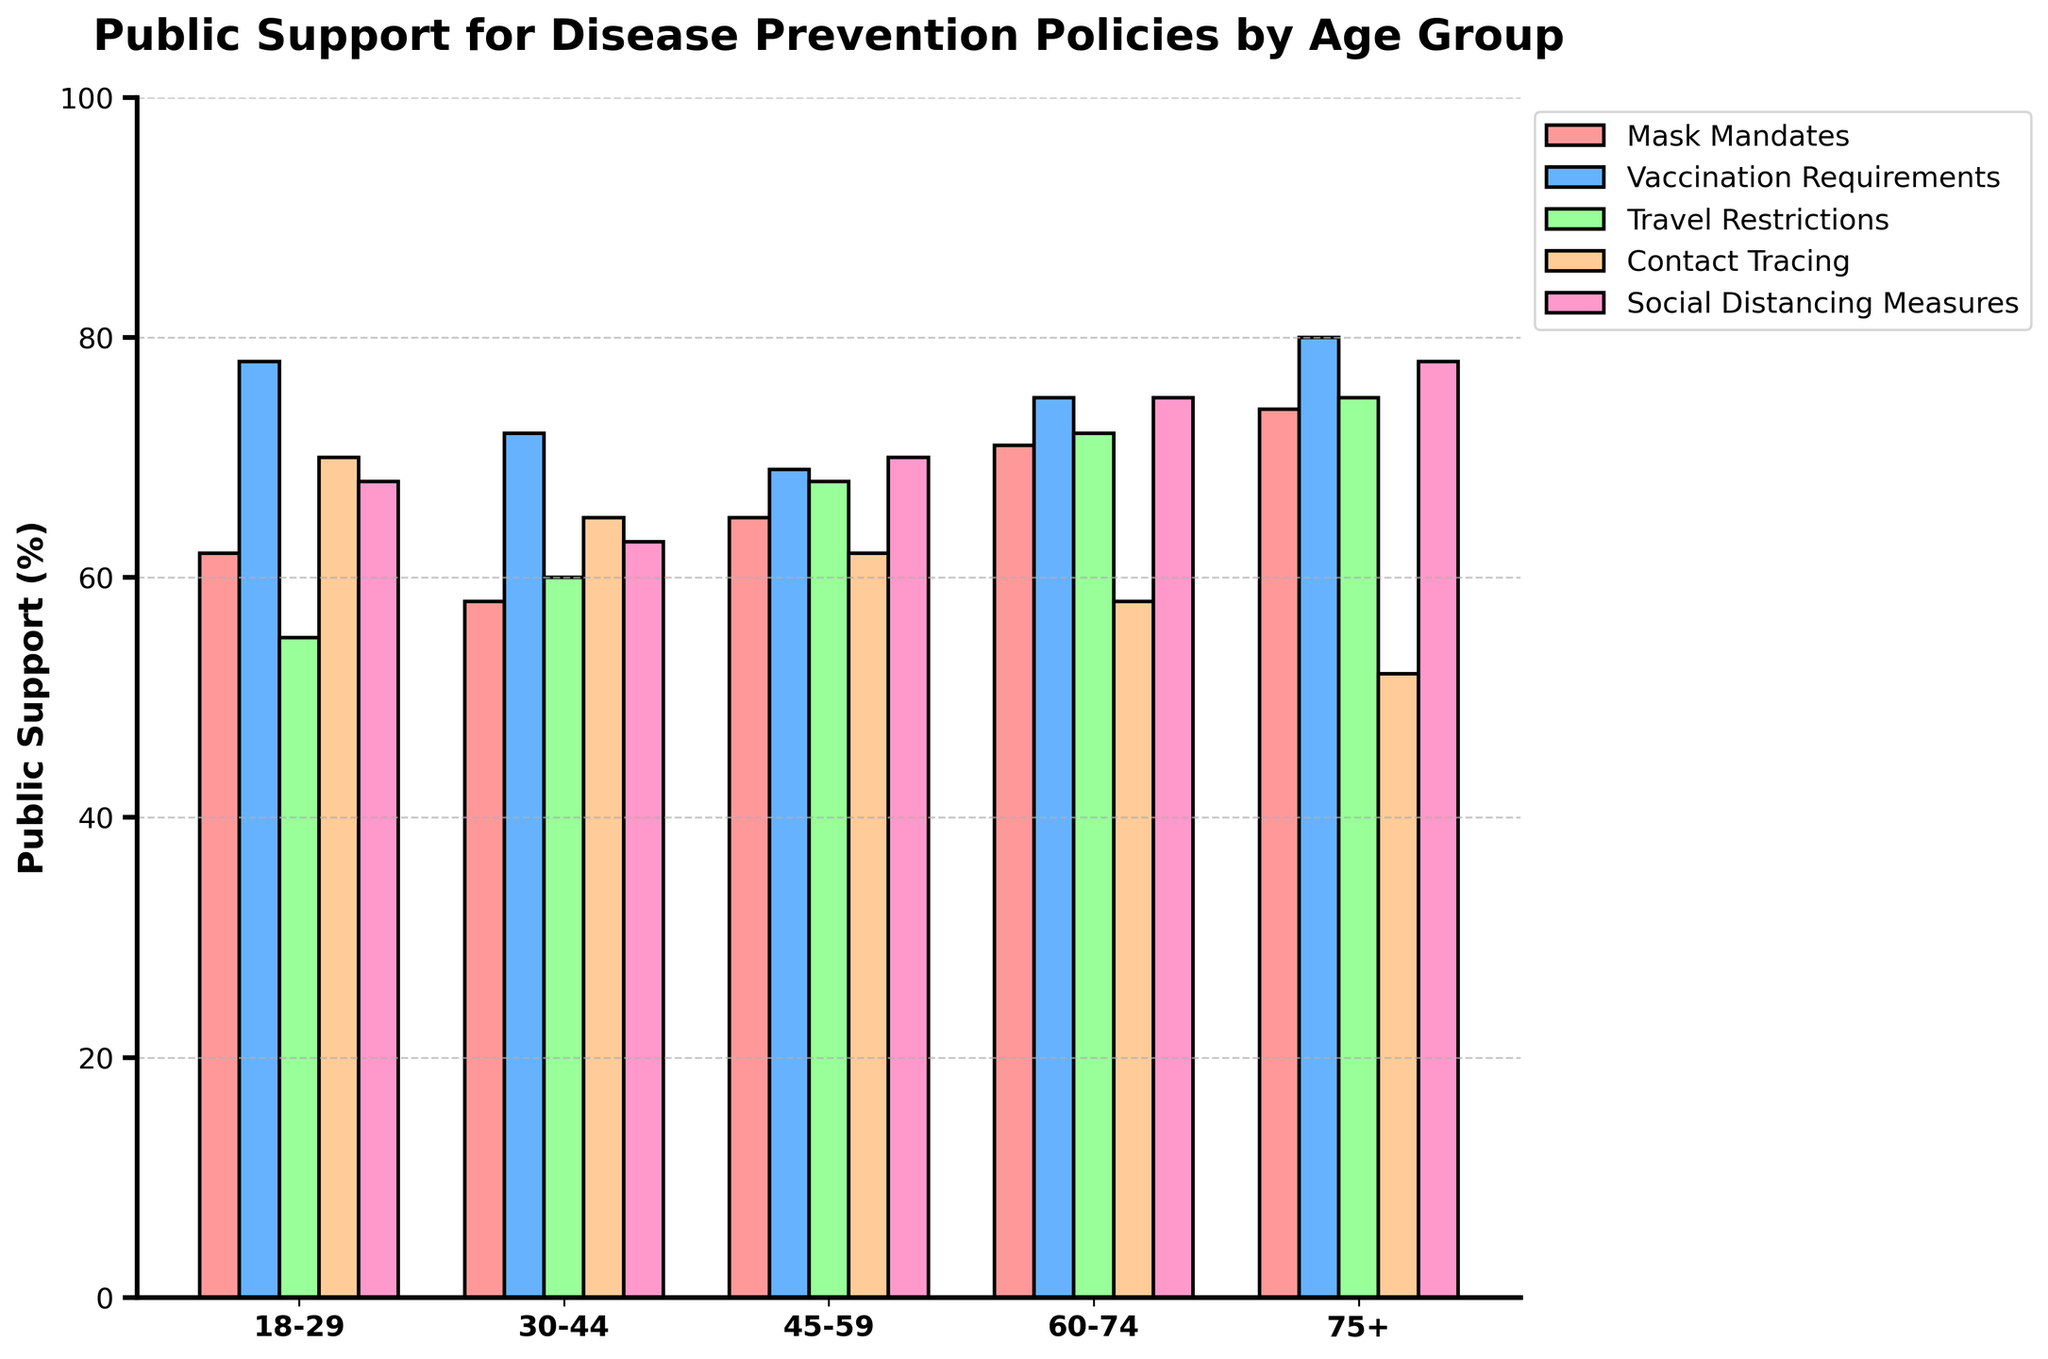What's the most supported disease prevention policy among the 18-29 age group? Look at the bars under the "18-29" section and identify which bar has the highest value. The "Vaccination Requirements" bar is the tallest.
Answer: Vaccination Requirements Which age group supports "Social Distancing Measures" the most? Compare the heights of the "Social Distancing Measures" bars across all age groups. The 75+ age group has the tallest bar for this policy.
Answer: 75+ What's the average support for "Travel Restrictions" across all age groups? Sum the percentages for "Travel Restrictions" across all age groups and then divide by the number of age groups: (55 + 60 + 68 + 72 + 75) / 5 = 66.
Answer: 66 How much greater is the support for "Mask Mandates" between the 75+ and the 30-44 age groups? Find the difference between the "Mask Mandates" support rates for the 75+ and 30-44 age groups: 74 - 58 = 16.
Answer: 16 Which policy has the least variation in support across all age groups? Calculate the range (max - min) for each policy and identify the one with the smallest range. "Vaccination Requirements" has the smallest range: 80 - 69 = 11.
Answer: Vaccination Requirements What's the average support for all policies in the 45-59 age group? Sum the support values for each policy in the 45-59 age group and divide by the number of policies: (65 + 69 + 68 + 62 + 70) / 5 = 66.8.
Answer: 66.8 Which policies have higher support in the 60-74 age group compared to the 45-59 age group? Compare the support values for each policy in the 60-74 and 45-59 age groups. "Mask Mandates" (71 > 65), "Vaccination Requirements" (75 > 69), and "Travel Restrictions" (72 > 68) have higher support.
Answer: Mask Mandates, Vaccination Requirements, Travel Restrictions What are the three most supported policies in the 75+ age group? Identify the three tallest bars in the 75+ age group section. They are "Vaccination Requirements," "Mask Mandates," and "Social Distancing Measures."
Answer: Vaccination Requirements, Mask Mandates, Social Distancing Measures What is the support difference for "Contact Tracing" between the 18-29 and 60-74 age groups? Find the difference in the support percentages for "Contact Tracing" between the 18-29 and 60-74 age groups: 70 - 58 = 12.
Answer: 12 Which age group has the most balanced support for all policies (least variability)? Evaluate the range (max - min) of support values for each age group and find the smallest range. The 30-44 age group has the smallest range: 72 - 58 = 14.
Answer: 30-44 